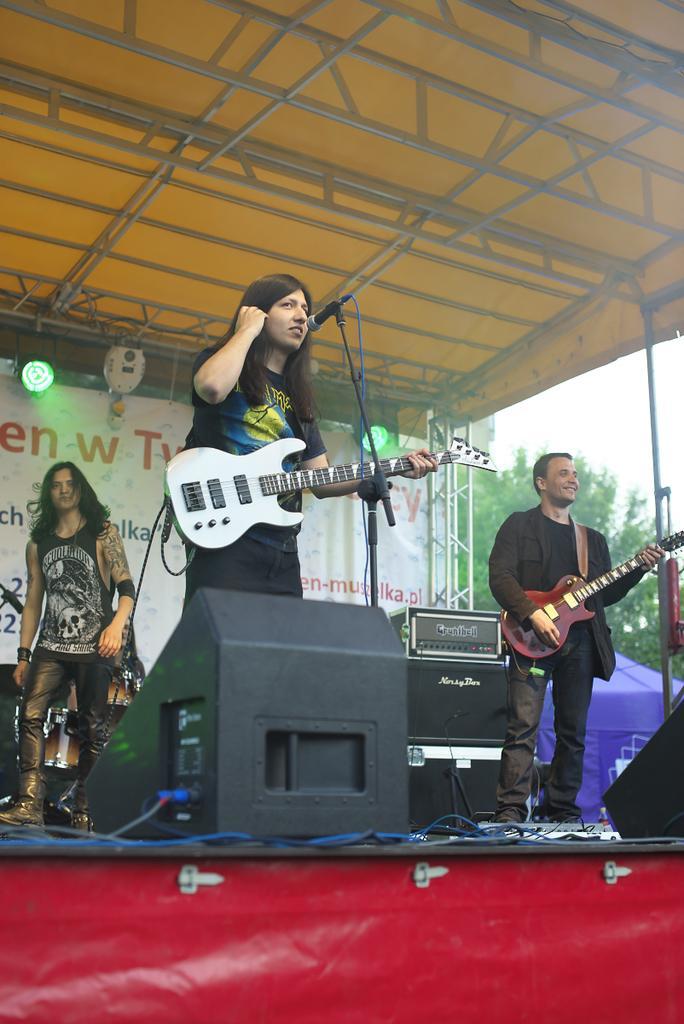Can you describe this image briefly? In this image, we can see a few people. Among them, two people are holding musical instruments. We can see some poles. On the top, we can see a shed and some rods. We can also see a stage with some objects on it. We can also see a poster with some text. We can also see some lights. There are some trees and we can see the sky. 